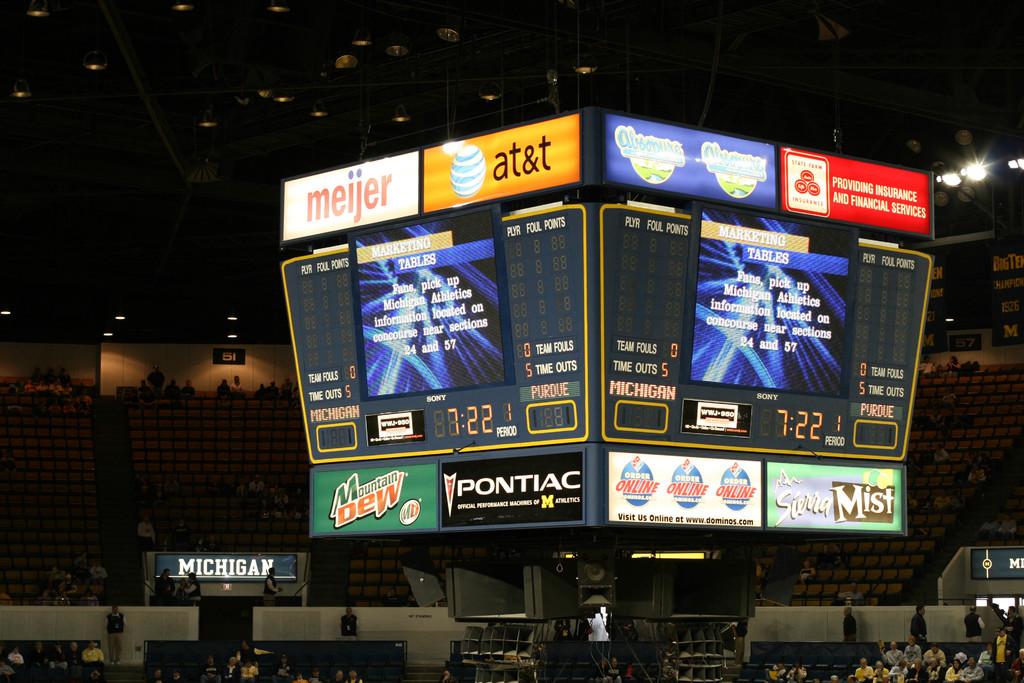What cellular company in orange is displayed here?
Your answer should be very brief. At&t. What soda is in green?
Offer a terse response. Mountain dew. 